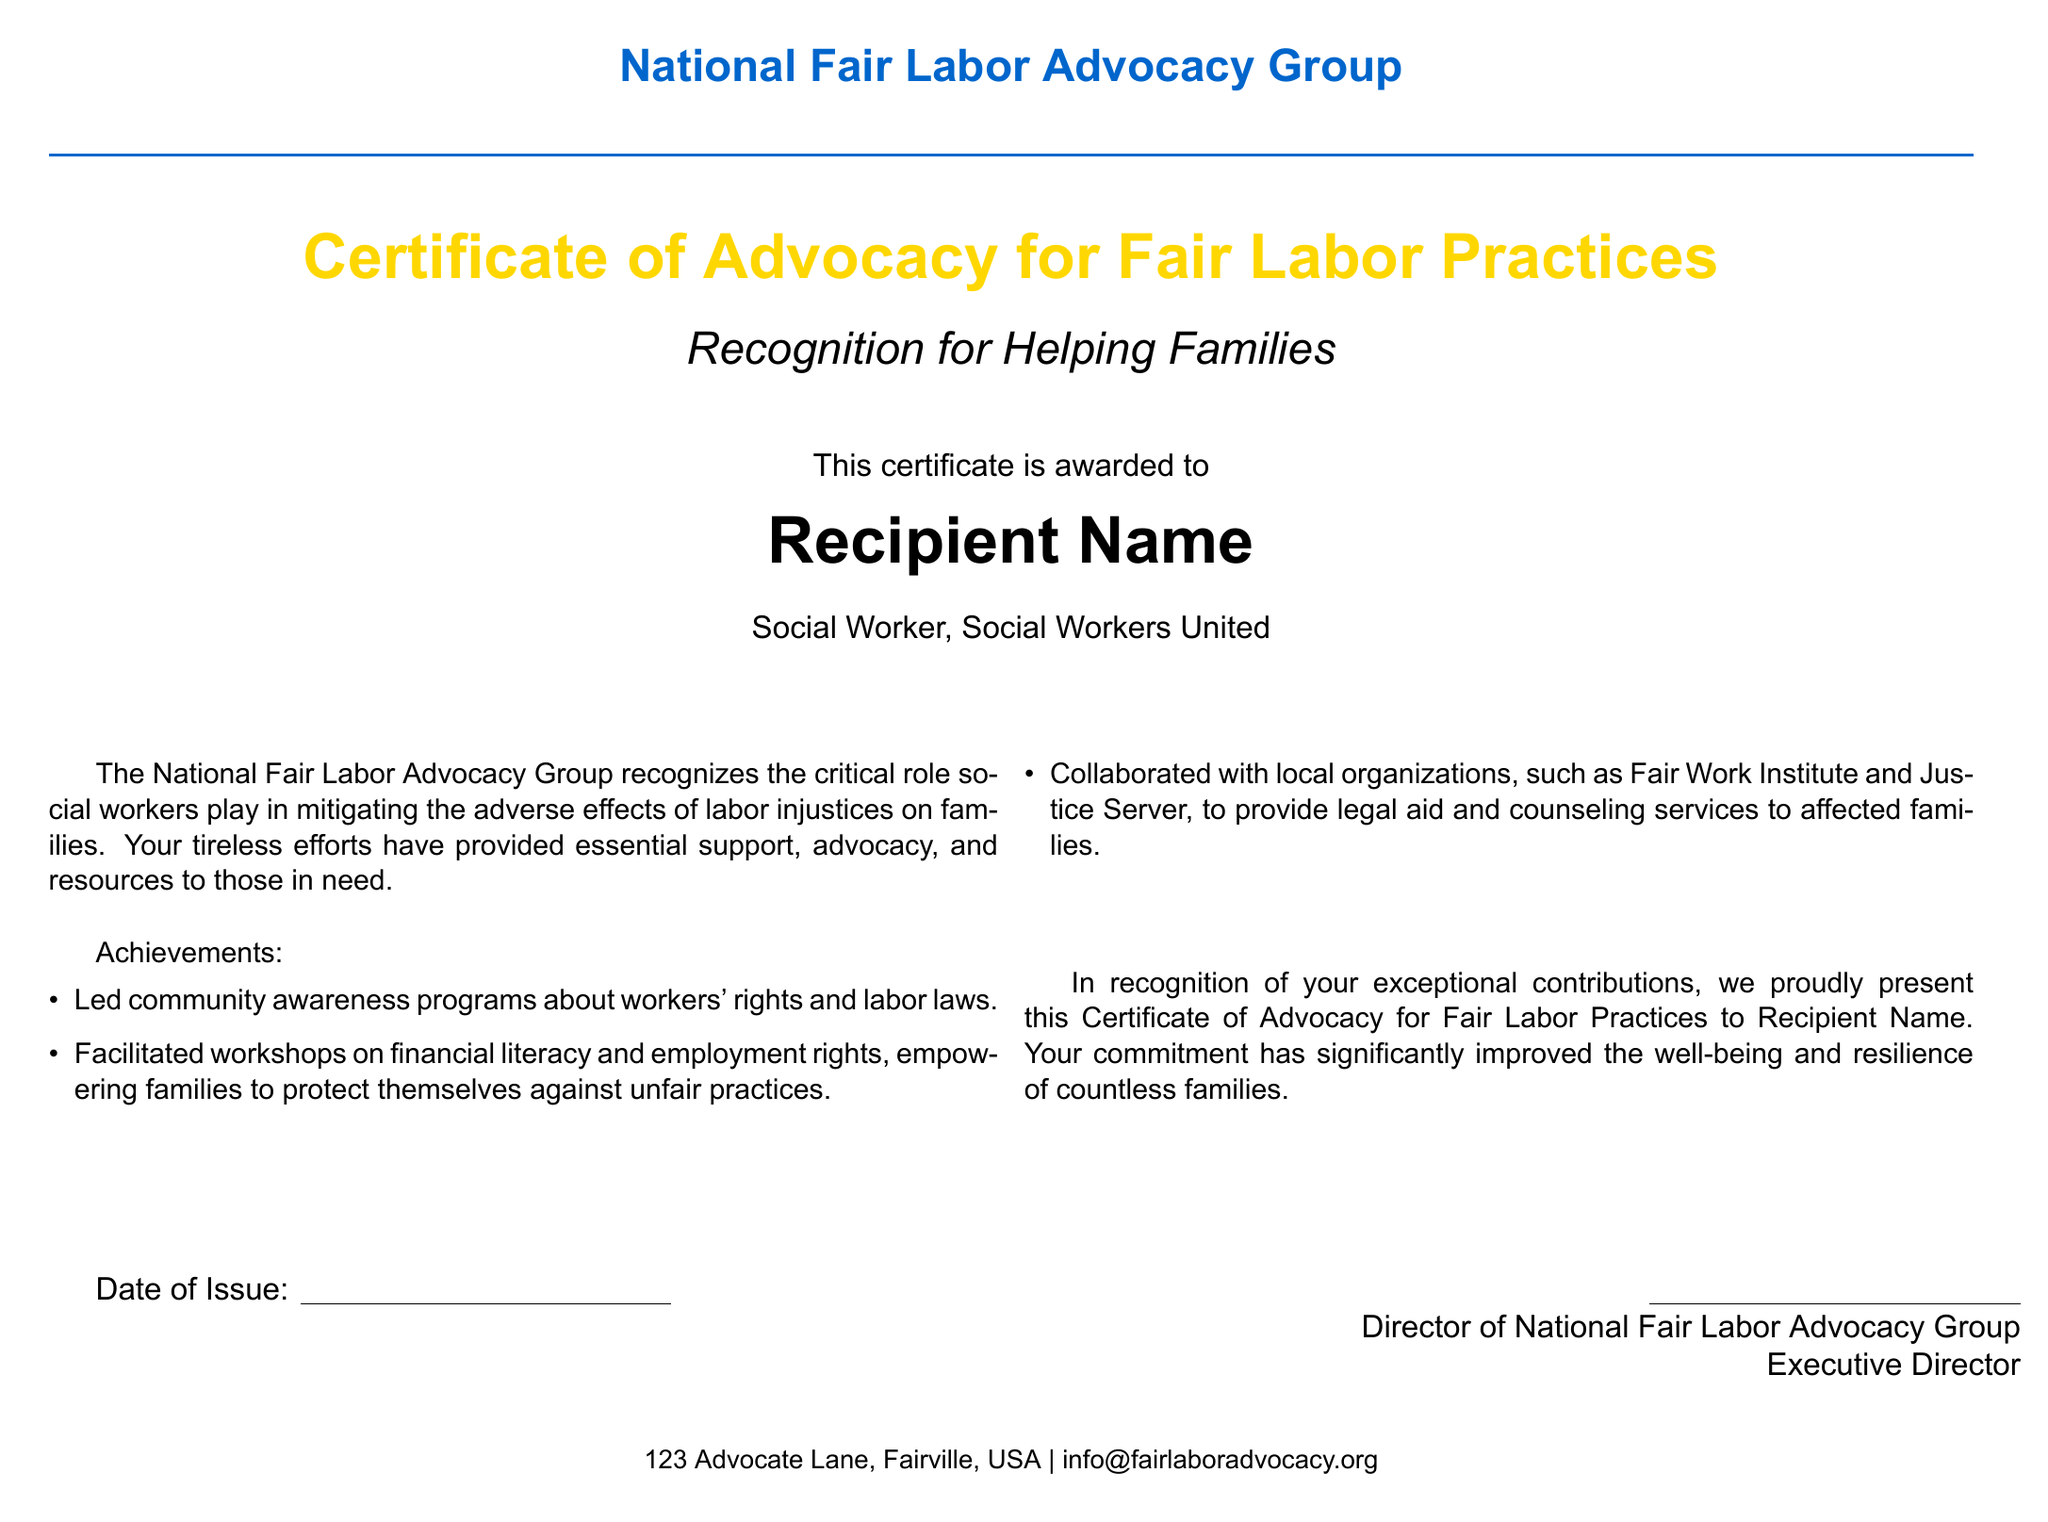What is the name of the group issuing the certificate? The certificate is issued by the National Fair Labor Advocacy Group, which is mentioned at the top of the document.
Answer: National Fair Labor Advocacy Group What is the title of the certificate? The title displayed prominently in the document is "Certificate of Advocacy for Fair Labor Practices."
Answer: Certificate of Advocacy for Fair Labor Practices Who is the recipient of the certificate? The document has a placeholder for "Recipient Name," where the name of the awarded individual would be filled in.
Answer: Recipient Name What is one of the achievements recognized in the certificate? One listed achievement in the document is "Led community awareness programs about workers' rights and labor laws."
Answer: Led community awareness programs about workers' rights and labor laws Who is the Executive Director that signed the certificate? The certificate has a space for the Director's signature, but does not provide a specific name, only a title.
Answer: Director of National Fair Labor Advocacy Group What is the date of issue represented as in the document? The document includes a line for the date of issue, but it does not specify the actual date.
Answer: Date of Issue What is the purpose of this certificate according to the document? The purpose of the certificate is to recognize the contributions made by the recipient towards fair labor practices and supporting families.
Answer: Recognition for Helping Families 